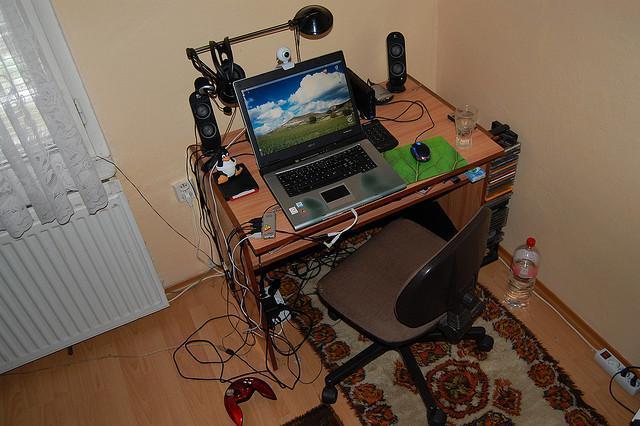How many monitors can be seen?
Give a very brief answer. 1. How many elephant are in the photo?
Give a very brief answer. 0. 